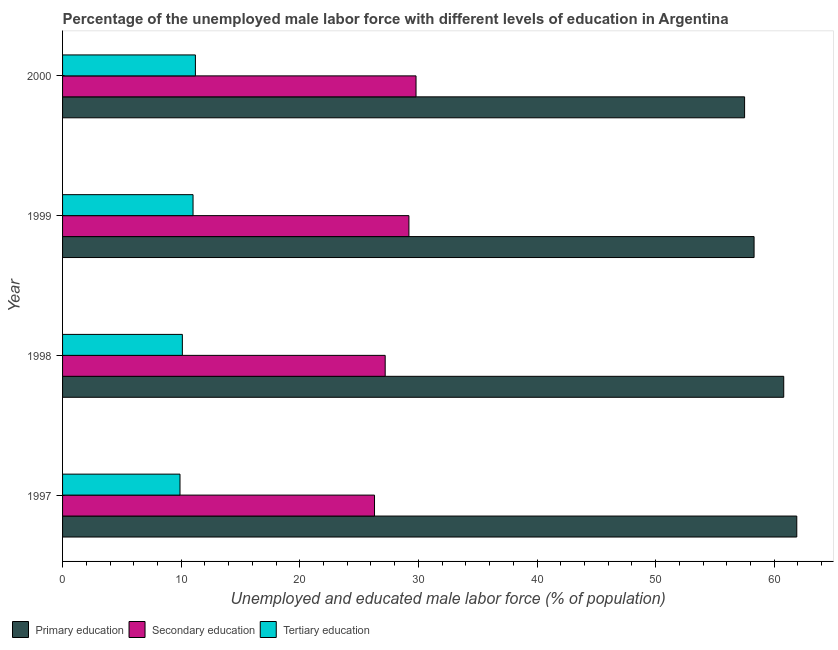How many groups of bars are there?
Provide a short and direct response. 4. Are the number of bars per tick equal to the number of legend labels?
Provide a short and direct response. Yes. What is the label of the 1st group of bars from the top?
Make the answer very short. 2000. What is the percentage of male labor force who received tertiary education in 1999?
Offer a terse response. 11. Across all years, what is the maximum percentage of male labor force who received primary education?
Offer a terse response. 61.9. Across all years, what is the minimum percentage of male labor force who received primary education?
Give a very brief answer. 57.5. In which year was the percentage of male labor force who received primary education maximum?
Make the answer very short. 1997. What is the total percentage of male labor force who received tertiary education in the graph?
Your response must be concise. 42.2. What is the difference between the percentage of male labor force who received primary education in 1999 and the percentage of male labor force who received tertiary education in 2000?
Offer a very short reply. 47.1. What is the average percentage of male labor force who received secondary education per year?
Provide a succinct answer. 28.12. In the year 2000, what is the difference between the percentage of male labor force who received secondary education and percentage of male labor force who received primary education?
Keep it short and to the point. -27.7. What is the ratio of the percentage of male labor force who received tertiary education in 1997 to that in 1999?
Make the answer very short. 0.9. Is the percentage of male labor force who received tertiary education in 1997 less than that in 2000?
Offer a terse response. Yes. What is the difference between the highest and the second highest percentage of male labor force who received secondary education?
Your answer should be very brief. 0.6. What is the difference between the highest and the lowest percentage of male labor force who received tertiary education?
Give a very brief answer. 1.3. In how many years, is the percentage of male labor force who received primary education greater than the average percentage of male labor force who received primary education taken over all years?
Make the answer very short. 2. What does the 1st bar from the top in 1998 represents?
Provide a succinct answer. Tertiary education. What does the 3rd bar from the bottom in 2000 represents?
Keep it short and to the point. Tertiary education. Is it the case that in every year, the sum of the percentage of male labor force who received primary education and percentage of male labor force who received secondary education is greater than the percentage of male labor force who received tertiary education?
Offer a terse response. Yes. How many years are there in the graph?
Provide a short and direct response. 4. What is the difference between two consecutive major ticks on the X-axis?
Offer a very short reply. 10. Are the values on the major ticks of X-axis written in scientific E-notation?
Your answer should be very brief. No. Does the graph contain any zero values?
Give a very brief answer. No. Does the graph contain grids?
Ensure brevity in your answer.  No. How many legend labels are there?
Keep it short and to the point. 3. What is the title of the graph?
Keep it short and to the point. Percentage of the unemployed male labor force with different levels of education in Argentina. Does "Tertiary" appear as one of the legend labels in the graph?
Provide a succinct answer. No. What is the label or title of the X-axis?
Your response must be concise. Unemployed and educated male labor force (% of population). What is the Unemployed and educated male labor force (% of population) of Primary education in 1997?
Ensure brevity in your answer.  61.9. What is the Unemployed and educated male labor force (% of population) in Secondary education in 1997?
Provide a short and direct response. 26.3. What is the Unemployed and educated male labor force (% of population) in Tertiary education in 1997?
Your answer should be compact. 9.9. What is the Unemployed and educated male labor force (% of population) in Primary education in 1998?
Provide a succinct answer. 60.8. What is the Unemployed and educated male labor force (% of population) in Secondary education in 1998?
Your answer should be compact. 27.2. What is the Unemployed and educated male labor force (% of population) of Tertiary education in 1998?
Keep it short and to the point. 10.1. What is the Unemployed and educated male labor force (% of population) in Primary education in 1999?
Your answer should be compact. 58.3. What is the Unemployed and educated male labor force (% of population) in Secondary education in 1999?
Provide a short and direct response. 29.2. What is the Unemployed and educated male labor force (% of population) of Primary education in 2000?
Provide a short and direct response. 57.5. What is the Unemployed and educated male labor force (% of population) of Secondary education in 2000?
Make the answer very short. 29.8. What is the Unemployed and educated male labor force (% of population) of Tertiary education in 2000?
Ensure brevity in your answer.  11.2. Across all years, what is the maximum Unemployed and educated male labor force (% of population) of Primary education?
Provide a short and direct response. 61.9. Across all years, what is the maximum Unemployed and educated male labor force (% of population) of Secondary education?
Your answer should be very brief. 29.8. Across all years, what is the maximum Unemployed and educated male labor force (% of population) of Tertiary education?
Offer a very short reply. 11.2. Across all years, what is the minimum Unemployed and educated male labor force (% of population) in Primary education?
Keep it short and to the point. 57.5. Across all years, what is the minimum Unemployed and educated male labor force (% of population) of Secondary education?
Your answer should be very brief. 26.3. Across all years, what is the minimum Unemployed and educated male labor force (% of population) of Tertiary education?
Provide a succinct answer. 9.9. What is the total Unemployed and educated male labor force (% of population) in Primary education in the graph?
Your answer should be compact. 238.5. What is the total Unemployed and educated male labor force (% of population) in Secondary education in the graph?
Your answer should be compact. 112.5. What is the total Unemployed and educated male labor force (% of population) of Tertiary education in the graph?
Keep it short and to the point. 42.2. What is the difference between the Unemployed and educated male labor force (% of population) of Tertiary education in 1997 and that in 1998?
Your response must be concise. -0.2. What is the difference between the Unemployed and educated male labor force (% of population) in Primary education in 1997 and that in 1999?
Your answer should be very brief. 3.6. What is the difference between the Unemployed and educated male labor force (% of population) in Tertiary education in 1997 and that in 1999?
Make the answer very short. -1.1. What is the difference between the Unemployed and educated male labor force (% of population) of Primary education in 1997 and that in 2000?
Your response must be concise. 4.4. What is the difference between the Unemployed and educated male labor force (% of population) of Secondary education in 1997 and that in 2000?
Ensure brevity in your answer.  -3.5. What is the difference between the Unemployed and educated male labor force (% of population) in Primary education in 1998 and that in 1999?
Provide a succinct answer. 2.5. What is the difference between the Unemployed and educated male labor force (% of population) of Secondary education in 1998 and that in 1999?
Your answer should be compact. -2. What is the difference between the Unemployed and educated male labor force (% of population) of Tertiary education in 1998 and that in 1999?
Keep it short and to the point. -0.9. What is the difference between the Unemployed and educated male labor force (% of population) of Primary education in 1998 and that in 2000?
Give a very brief answer. 3.3. What is the difference between the Unemployed and educated male labor force (% of population) of Secondary education in 1998 and that in 2000?
Provide a short and direct response. -2.6. What is the difference between the Unemployed and educated male labor force (% of population) of Tertiary education in 1998 and that in 2000?
Provide a succinct answer. -1.1. What is the difference between the Unemployed and educated male labor force (% of population) of Primary education in 1999 and that in 2000?
Offer a terse response. 0.8. What is the difference between the Unemployed and educated male labor force (% of population) in Secondary education in 1999 and that in 2000?
Your response must be concise. -0.6. What is the difference between the Unemployed and educated male labor force (% of population) in Tertiary education in 1999 and that in 2000?
Provide a succinct answer. -0.2. What is the difference between the Unemployed and educated male labor force (% of population) in Primary education in 1997 and the Unemployed and educated male labor force (% of population) in Secondary education in 1998?
Your answer should be very brief. 34.7. What is the difference between the Unemployed and educated male labor force (% of population) of Primary education in 1997 and the Unemployed and educated male labor force (% of population) of Tertiary education in 1998?
Give a very brief answer. 51.8. What is the difference between the Unemployed and educated male labor force (% of population) in Secondary education in 1997 and the Unemployed and educated male labor force (% of population) in Tertiary education in 1998?
Your answer should be very brief. 16.2. What is the difference between the Unemployed and educated male labor force (% of population) in Primary education in 1997 and the Unemployed and educated male labor force (% of population) in Secondary education in 1999?
Your response must be concise. 32.7. What is the difference between the Unemployed and educated male labor force (% of population) in Primary education in 1997 and the Unemployed and educated male labor force (% of population) in Tertiary education in 1999?
Your answer should be very brief. 50.9. What is the difference between the Unemployed and educated male labor force (% of population) in Secondary education in 1997 and the Unemployed and educated male labor force (% of population) in Tertiary education in 1999?
Give a very brief answer. 15.3. What is the difference between the Unemployed and educated male labor force (% of population) in Primary education in 1997 and the Unemployed and educated male labor force (% of population) in Secondary education in 2000?
Provide a succinct answer. 32.1. What is the difference between the Unemployed and educated male labor force (% of population) of Primary education in 1997 and the Unemployed and educated male labor force (% of population) of Tertiary education in 2000?
Make the answer very short. 50.7. What is the difference between the Unemployed and educated male labor force (% of population) of Secondary education in 1997 and the Unemployed and educated male labor force (% of population) of Tertiary education in 2000?
Keep it short and to the point. 15.1. What is the difference between the Unemployed and educated male labor force (% of population) of Primary education in 1998 and the Unemployed and educated male labor force (% of population) of Secondary education in 1999?
Give a very brief answer. 31.6. What is the difference between the Unemployed and educated male labor force (% of population) in Primary education in 1998 and the Unemployed and educated male labor force (% of population) in Tertiary education in 1999?
Your answer should be compact. 49.8. What is the difference between the Unemployed and educated male labor force (% of population) of Primary education in 1998 and the Unemployed and educated male labor force (% of population) of Tertiary education in 2000?
Make the answer very short. 49.6. What is the difference between the Unemployed and educated male labor force (% of population) in Primary education in 1999 and the Unemployed and educated male labor force (% of population) in Secondary education in 2000?
Give a very brief answer. 28.5. What is the difference between the Unemployed and educated male labor force (% of population) of Primary education in 1999 and the Unemployed and educated male labor force (% of population) of Tertiary education in 2000?
Keep it short and to the point. 47.1. What is the average Unemployed and educated male labor force (% of population) in Primary education per year?
Offer a very short reply. 59.62. What is the average Unemployed and educated male labor force (% of population) of Secondary education per year?
Give a very brief answer. 28.12. What is the average Unemployed and educated male labor force (% of population) of Tertiary education per year?
Your response must be concise. 10.55. In the year 1997, what is the difference between the Unemployed and educated male labor force (% of population) of Primary education and Unemployed and educated male labor force (% of population) of Secondary education?
Your answer should be very brief. 35.6. In the year 1997, what is the difference between the Unemployed and educated male labor force (% of population) of Primary education and Unemployed and educated male labor force (% of population) of Tertiary education?
Keep it short and to the point. 52. In the year 1998, what is the difference between the Unemployed and educated male labor force (% of population) in Primary education and Unemployed and educated male labor force (% of population) in Secondary education?
Give a very brief answer. 33.6. In the year 1998, what is the difference between the Unemployed and educated male labor force (% of population) in Primary education and Unemployed and educated male labor force (% of population) in Tertiary education?
Offer a terse response. 50.7. In the year 1998, what is the difference between the Unemployed and educated male labor force (% of population) in Secondary education and Unemployed and educated male labor force (% of population) in Tertiary education?
Keep it short and to the point. 17.1. In the year 1999, what is the difference between the Unemployed and educated male labor force (% of population) in Primary education and Unemployed and educated male labor force (% of population) in Secondary education?
Provide a succinct answer. 29.1. In the year 1999, what is the difference between the Unemployed and educated male labor force (% of population) of Primary education and Unemployed and educated male labor force (% of population) of Tertiary education?
Ensure brevity in your answer.  47.3. In the year 1999, what is the difference between the Unemployed and educated male labor force (% of population) of Secondary education and Unemployed and educated male labor force (% of population) of Tertiary education?
Provide a succinct answer. 18.2. In the year 2000, what is the difference between the Unemployed and educated male labor force (% of population) of Primary education and Unemployed and educated male labor force (% of population) of Secondary education?
Your answer should be compact. 27.7. In the year 2000, what is the difference between the Unemployed and educated male labor force (% of population) in Primary education and Unemployed and educated male labor force (% of population) in Tertiary education?
Ensure brevity in your answer.  46.3. In the year 2000, what is the difference between the Unemployed and educated male labor force (% of population) in Secondary education and Unemployed and educated male labor force (% of population) in Tertiary education?
Give a very brief answer. 18.6. What is the ratio of the Unemployed and educated male labor force (% of population) of Primary education in 1997 to that in 1998?
Ensure brevity in your answer.  1.02. What is the ratio of the Unemployed and educated male labor force (% of population) in Secondary education in 1997 to that in 1998?
Provide a short and direct response. 0.97. What is the ratio of the Unemployed and educated male labor force (% of population) in Tertiary education in 1997 to that in 1998?
Make the answer very short. 0.98. What is the ratio of the Unemployed and educated male labor force (% of population) of Primary education in 1997 to that in 1999?
Provide a succinct answer. 1.06. What is the ratio of the Unemployed and educated male labor force (% of population) in Secondary education in 1997 to that in 1999?
Offer a very short reply. 0.9. What is the ratio of the Unemployed and educated male labor force (% of population) in Primary education in 1997 to that in 2000?
Provide a succinct answer. 1.08. What is the ratio of the Unemployed and educated male labor force (% of population) of Secondary education in 1997 to that in 2000?
Offer a very short reply. 0.88. What is the ratio of the Unemployed and educated male labor force (% of population) of Tertiary education in 1997 to that in 2000?
Offer a terse response. 0.88. What is the ratio of the Unemployed and educated male labor force (% of population) in Primary education in 1998 to that in 1999?
Your response must be concise. 1.04. What is the ratio of the Unemployed and educated male labor force (% of population) in Secondary education in 1998 to that in 1999?
Offer a very short reply. 0.93. What is the ratio of the Unemployed and educated male labor force (% of population) of Tertiary education in 1998 to that in 1999?
Provide a short and direct response. 0.92. What is the ratio of the Unemployed and educated male labor force (% of population) of Primary education in 1998 to that in 2000?
Offer a very short reply. 1.06. What is the ratio of the Unemployed and educated male labor force (% of population) in Secondary education in 1998 to that in 2000?
Provide a succinct answer. 0.91. What is the ratio of the Unemployed and educated male labor force (% of population) of Tertiary education in 1998 to that in 2000?
Your response must be concise. 0.9. What is the ratio of the Unemployed and educated male labor force (% of population) of Primary education in 1999 to that in 2000?
Offer a very short reply. 1.01. What is the ratio of the Unemployed and educated male labor force (% of population) in Secondary education in 1999 to that in 2000?
Your answer should be very brief. 0.98. What is the ratio of the Unemployed and educated male labor force (% of population) of Tertiary education in 1999 to that in 2000?
Provide a succinct answer. 0.98. What is the difference between the highest and the second highest Unemployed and educated male labor force (% of population) in Primary education?
Offer a very short reply. 1.1. What is the difference between the highest and the second highest Unemployed and educated male labor force (% of population) in Secondary education?
Your response must be concise. 0.6. What is the difference between the highest and the lowest Unemployed and educated male labor force (% of population) in Primary education?
Give a very brief answer. 4.4. What is the difference between the highest and the lowest Unemployed and educated male labor force (% of population) of Secondary education?
Ensure brevity in your answer.  3.5. What is the difference between the highest and the lowest Unemployed and educated male labor force (% of population) in Tertiary education?
Ensure brevity in your answer.  1.3. 